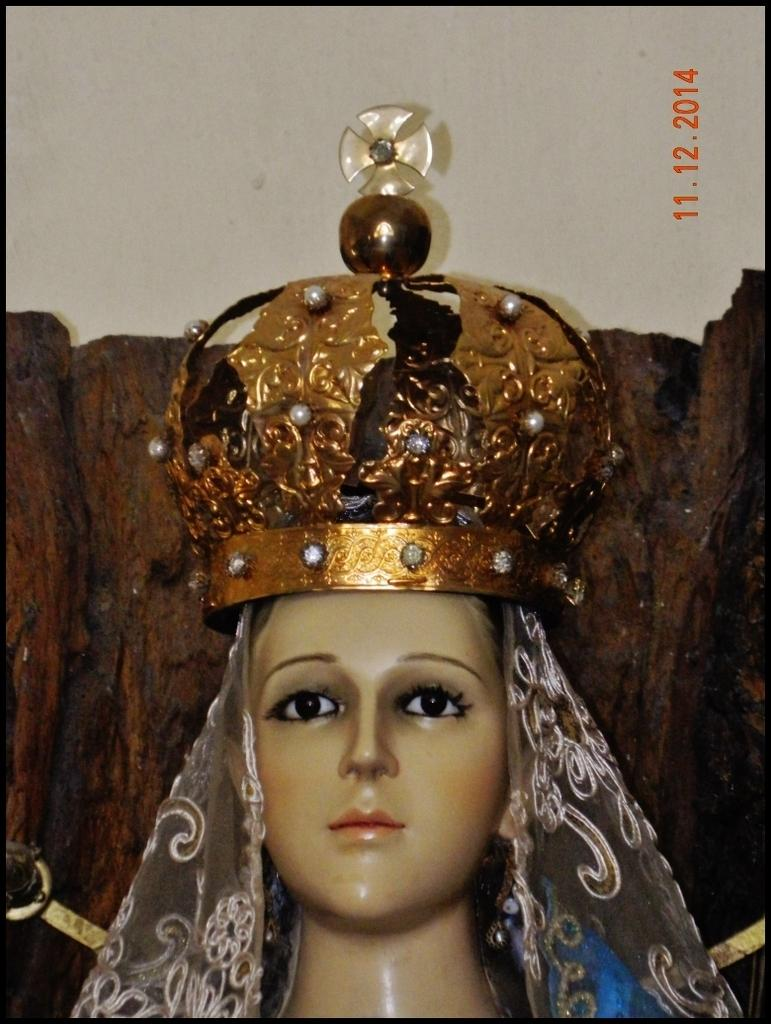What is the main subject of the image? There is a sculpture of a lady in the image. Can you describe any additional elements in the image? There is some text on the right side of the image. What type of pancake is being served to the women in the image? There are no women or pancakes present in the image; it features a sculpture of a lady and some text. 